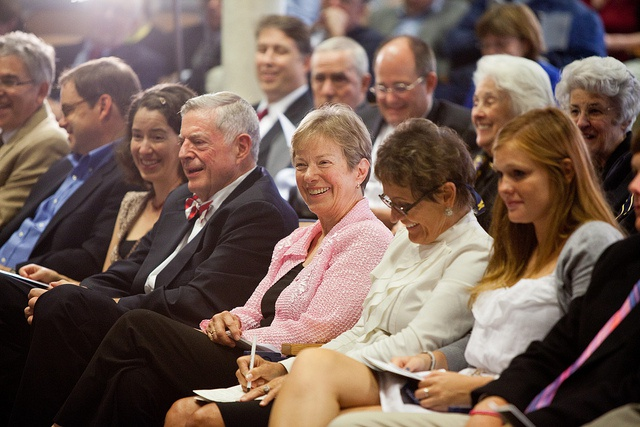Describe the objects in this image and their specific colors. I can see people in gray, maroon, black, lightgray, and tan tones, people in gray, black, and brown tones, people in gray, black, lightpink, lightgray, and brown tones, people in gray, beige, lightgray, maroon, and black tones, and people in gray, black, beige, and lightpink tones in this image. 